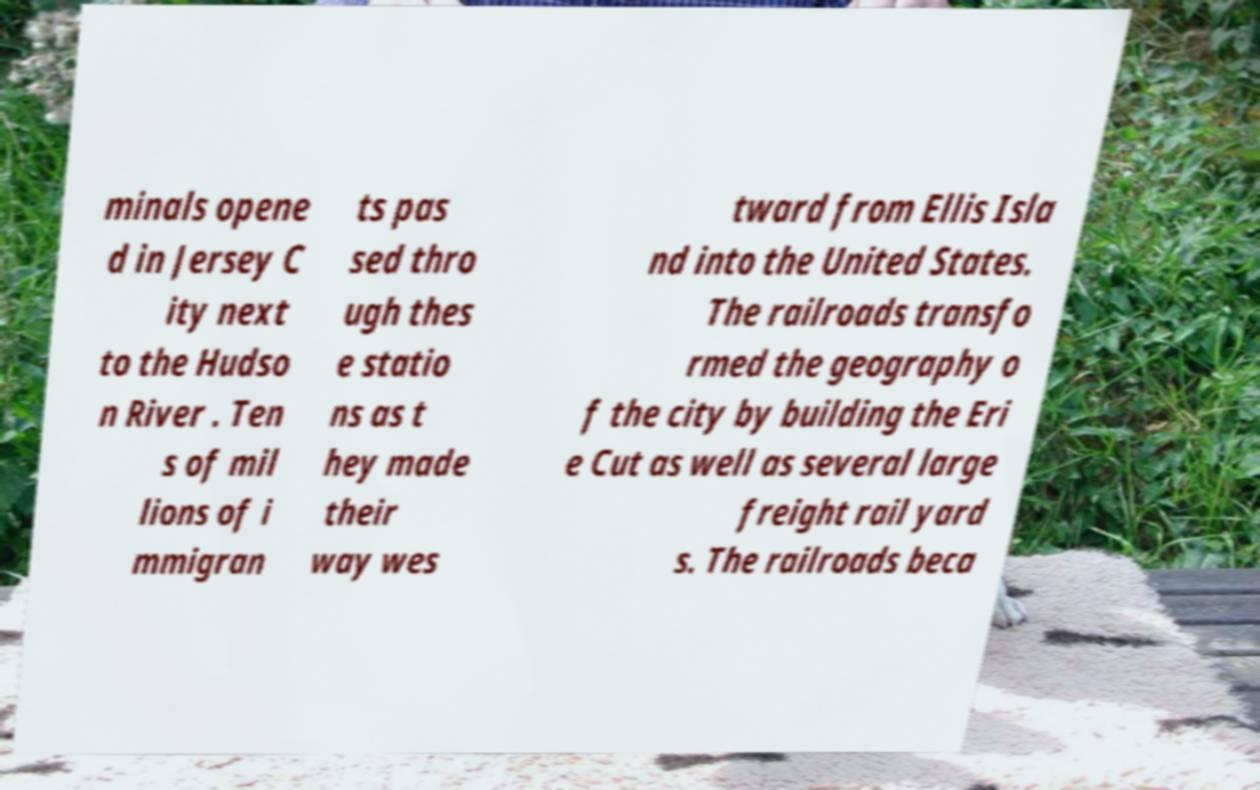There's text embedded in this image that I need extracted. Can you transcribe it verbatim? minals opene d in Jersey C ity next to the Hudso n River . Ten s of mil lions of i mmigran ts pas sed thro ugh thes e statio ns as t hey made their way wes tward from Ellis Isla nd into the United States. The railroads transfo rmed the geography o f the city by building the Eri e Cut as well as several large freight rail yard s. The railroads beca 